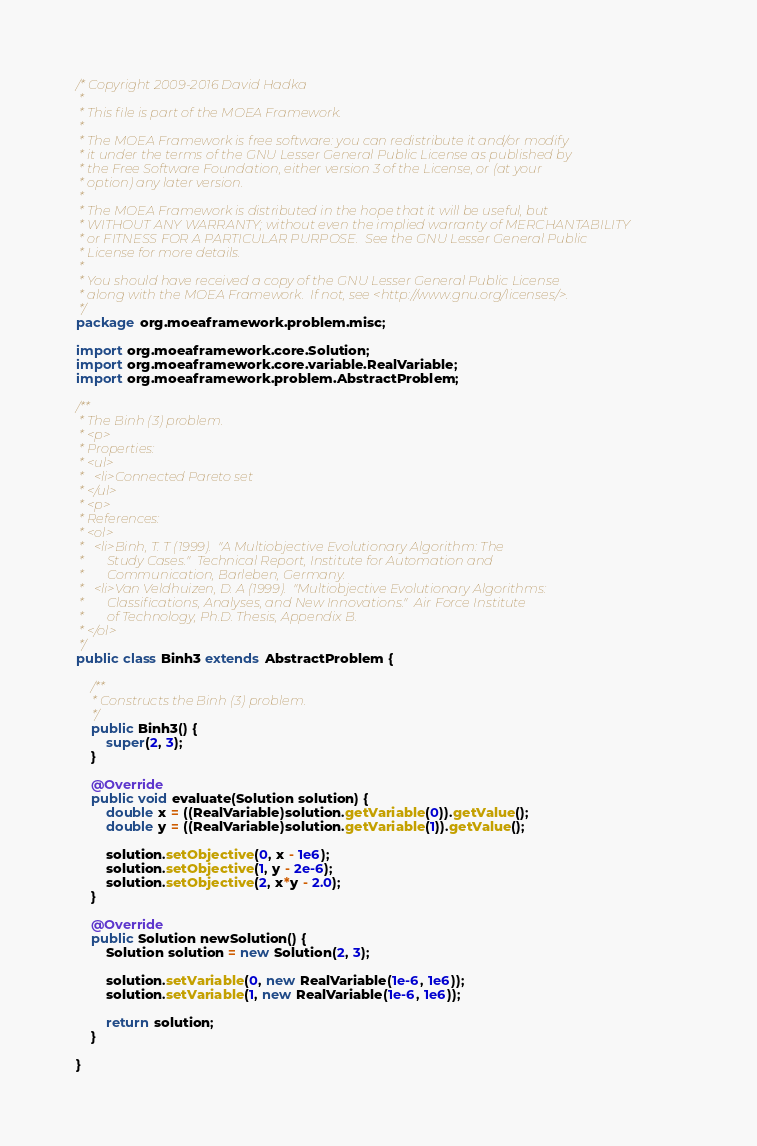<code> <loc_0><loc_0><loc_500><loc_500><_Java_>/* Copyright 2009-2016 David Hadka
 *
 * This file is part of the MOEA Framework.
 *
 * The MOEA Framework is free software: you can redistribute it and/or modify
 * it under the terms of the GNU Lesser General Public License as published by
 * the Free Software Foundation, either version 3 of the License, or (at your
 * option) any later version.
 *
 * The MOEA Framework is distributed in the hope that it will be useful, but
 * WITHOUT ANY WARRANTY; without even the implied warranty of MERCHANTABILITY
 * or FITNESS FOR A PARTICULAR PURPOSE.  See the GNU Lesser General Public
 * License for more details.
 *
 * You should have received a copy of the GNU Lesser General Public License
 * along with the MOEA Framework.  If not, see <http://www.gnu.org/licenses/>.
 */
package org.moeaframework.problem.misc;

import org.moeaframework.core.Solution;
import org.moeaframework.core.variable.RealVariable;
import org.moeaframework.problem.AbstractProblem;

/**
 * The Binh (3) problem.
 * <p>
 * Properties:
 * <ul>
 *   <li>Connected Pareto set
 * </ul>
 * <p>
 * References:
 * <ol>
 *   <li>Binh, T. T (1999).  "A Multiobjective Evolutionary Algorithm: The
 *       Study Cases."  Technical Report, Institute for Automation and
 *       Communication, Barleben, Germany.
 *   <li>Van Veldhuizen, D. A (1999).  "Multiobjective Evolutionary Algorithms: 
 *       Classifications, Analyses, and New Innovations."  Air Force Institute
 *       of Technology, Ph.D. Thesis, Appendix B.
 * </ol>
 */
public class Binh3 extends AbstractProblem {

	/**
	 * Constructs the Binh (3) problem.
	 */
	public Binh3() {
		super(2, 3);
	}

	@Override
	public void evaluate(Solution solution) {
		double x = ((RealVariable)solution.getVariable(0)).getValue();
		double y = ((RealVariable)solution.getVariable(1)).getValue();
		
		solution.setObjective(0, x - 1e6);
		solution.setObjective(1, y - 2e-6);
		solution.setObjective(2, x*y - 2.0);
	}

	@Override
	public Solution newSolution() {
		Solution solution = new Solution(2, 3);
		
		solution.setVariable(0, new RealVariable(1e-6, 1e6));
		solution.setVariable(1, new RealVariable(1e-6, 1e6));
		
		return solution;
	}

}
</code> 